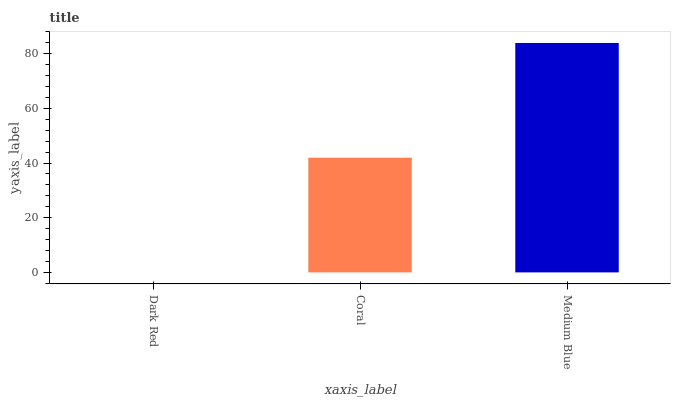Is Dark Red the minimum?
Answer yes or no. Yes. Is Medium Blue the maximum?
Answer yes or no. Yes. Is Coral the minimum?
Answer yes or no. No. Is Coral the maximum?
Answer yes or no. No. Is Coral greater than Dark Red?
Answer yes or no. Yes. Is Dark Red less than Coral?
Answer yes or no. Yes. Is Dark Red greater than Coral?
Answer yes or no. No. Is Coral less than Dark Red?
Answer yes or no. No. Is Coral the high median?
Answer yes or no. Yes. Is Coral the low median?
Answer yes or no. Yes. Is Medium Blue the high median?
Answer yes or no. No. Is Dark Red the low median?
Answer yes or no. No. 